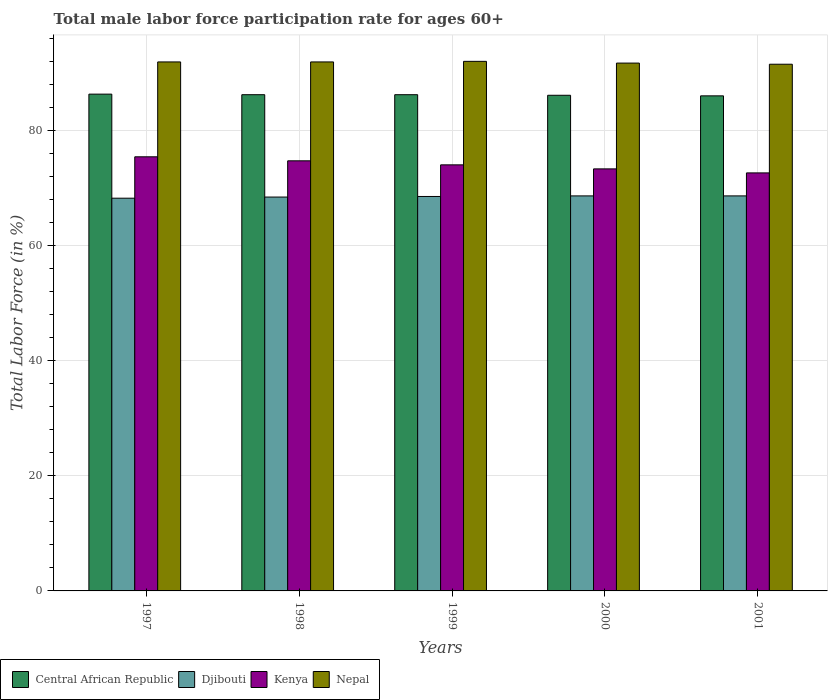How many different coloured bars are there?
Ensure brevity in your answer.  4. How many groups of bars are there?
Make the answer very short. 5. How many bars are there on the 5th tick from the left?
Your answer should be compact. 4. What is the male labor force participation rate in Kenya in 2000?
Ensure brevity in your answer.  73.4. Across all years, what is the maximum male labor force participation rate in Nepal?
Your answer should be very brief. 92.1. Across all years, what is the minimum male labor force participation rate in Djibouti?
Your response must be concise. 68.3. In which year was the male labor force participation rate in Nepal minimum?
Offer a very short reply. 2001. What is the total male labor force participation rate in Nepal in the graph?
Your answer should be very brief. 459.5. What is the difference between the male labor force participation rate in Kenya in 1997 and that in 1999?
Offer a very short reply. 1.4. What is the difference between the male labor force participation rate in Kenya in 1997 and the male labor force participation rate in Central African Republic in 1999?
Ensure brevity in your answer.  -10.8. What is the average male labor force participation rate in Djibouti per year?
Your answer should be very brief. 68.56. In the year 1999, what is the difference between the male labor force participation rate in Central African Republic and male labor force participation rate in Kenya?
Your answer should be compact. 12.2. In how many years, is the male labor force participation rate in Djibouti greater than 36 %?
Your answer should be compact. 5. What is the ratio of the male labor force participation rate in Djibouti in 1998 to that in 1999?
Provide a short and direct response. 1. What is the difference between the highest and the second highest male labor force participation rate in Nepal?
Give a very brief answer. 0.1. What is the difference between the highest and the lowest male labor force participation rate in Djibouti?
Ensure brevity in your answer.  0.4. In how many years, is the male labor force participation rate in Djibouti greater than the average male labor force participation rate in Djibouti taken over all years?
Provide a short and direct response. 3. Is it the case that in every year, the sum of the male labor force participation rate in Djibouti and male labor force participation rate in Kenya is greater than the sum of male labor force participation rate in Central African Republic and male labor force participation rate in Nepal?
Offer a very short reply. No. What does the 2nd bar from the left in 1997 represents?
Ensure brevity in your answer.  Djibouti. What does the 1st bar from the right in 1998 represents?
Offer a very short reply. Nepal. Is it the case that in every year, the sum of the male labor force participation rate in Djibouti and male labor force participation rate in Nepal is greater than the male labor force participation rate in Kenya?
Keep it short and to the point. Yes. Are the values on the major ticks of Y-axis written in scientific E-notation?
Make the answer very short. No. Does the graph contain any zero values?
Provide a short and direct response. No. Does the graph contain grids?
Your answer should be very brief. Yes. How many legend labels are there?
Make the answer very short. 4. How are the legend labels stacked?
Make the answer very short. Horizontal. What is the title of the graph?
Your answer should be compact. Total male labor force participation rate for ages 60+. What is the label or title of the X-axis?
Keep it short and to the point. Years. What is the label or title of the Y-axis?
Keep it short and to the point. Total Labor Force (in %). What is the Total Labor Force (in %) in Central African Republic in 1997?
Offer a very short reply. 86.4. What is the Total Labor Force (in %) in Djibouti in 1997?
Make the answer very short. 68.3. What is the Total Labor Force (in %) in Kenya in 1997?
Give a very brief answer. 75.5. What is the Total Labor Force (in %) of Nepal in 1997?
Ensure brevity in your answer.  92. What is the Total Labor Force (in %) of Central African Republic in 1998?
Make the answer very short. 86.3. What is the Total Labor Force (in %) in Djibouti in 1998?
Your answer should be compact. 68.5. What is the Total Labor Force (in %) in Kenya in 1998?
Offer a terse response. 74.8. What is the Total Labor Force (in %) in Nepal in 1998?
Give a very brief answer. 92. What is the Total Labor Force (in %) of Central African Republic in 1999?
Keep it short and to the point. 86.3. What is the Total Labor Force (in %) of Djibouti in 1999?
Your response must be concise. 68.6. What is the Total Labor Force (in %) of Kenya in 1999?
Your response must be concise. 74.1. What is the Total Labor Force (in %) in Nepal in 1999?
Keep it short and to the point. 92.1. What is the Total Labor Force (in %) in Central African Republic in 2000?
Keep it short and to the point. 86.2. What is the Total Labor Force (in %) of Djibouti in 2000?
Provide a short and direct response. 68.7. What is the Total Labor Force (in %) in Kenya in 2000?
Your answer should be compact. 73.4. What is the Total Labor Force (in %) of Nepal in 2000?
Provide a succinct answer. 91.8. What is the Total Labor Force (in %) of Central African Republic in 2001?
Your answer should be very brief. 86.1. What is the Total Labor Force (in %) in Djibouti in 2001?
Your answer should be compact. 68.7. What is the Total Labor Force (in %) of Kenya in 2001?
Give a very brief answer. 72.7. What is the Total Labor Force (in %) of Nepal in 2001?
Offer a very short reply. 91.6. Across all years, what is the maximum Total Labor Force (in %) of Central African Republic?
Your response must be concise. 86.4. Across all years, what is the maximum Total Labor Force (in %) in Djibouti?
Your answer should be very brief. 68.7. Across all years, what is the maximum Total Labor Force (in %) in Kenya?
Your answer should be compact. 75.5. Across all years, what is the maximum Total Labor Force (in %) of Nepal?
Provide a short and direct response. 92.1. Across all years, what is the minimum Total Labor Force (in %) in Central African Republic?
Keep it short and to the point. 86.1. Across all years, what is the minimum Total Labor Force (in %) in Djibouti?
Provide a succinct answer. 68.3. Across all years, what is the minimum Total Labor Force (in %) in Kenya?
Your answer should be very brief. 72.7. Across all years, what is the minimum Total Labor Force (in %) in Nepal?
Give a very brief answer. 91.6. What is the total Total Labor Force (in %) in Central African Republic in the graph?
Offer a terse response. 431.3. What is the total Total Labor Force (in %) of Djibouti in the graph?
Your answer should be compact. 342.8. What is the total Total Labor Force (in %) of Kenya in the graph?
Make the answer very short. 370.5. What is the total Total Labor Force (in %) of Nepal in the graph?
Ensure brevity in your answer.  459.5. What is the difference between the Total Labor Force (in %) of Central African Republic in 1997 and that in 1998?
Keep it short and to the point. 0.1. What is the difference between the Total Labor Force (in %) of Kenya in 1997 and that in 1998?
Keep it short and to the point. 0.7. What is the difference between the Total Labor Force (in %) of Nepal in 1997 and that in 1998?
Provide a succinct answer. 0. What is the difference between the Total Labor Force (in %) of Central African Republic in 1997 and that in 1999?
Offer a very short reply. 0.1. What is the difference between the Total Labor Force (in %) in Kenya in 1997 and that in 1999?
Your response must be concise. 1.4. What is the difference between the Total Labor Force (in %) of Central African Republic in 1997 and that in 2000?
Offer a terse response. 0.2. What is the difference between the Total Labor Force (in %) of Nepal in 1997 and that in 2000?
Give a very brief answer. 0.2. What is the difference between the Total Labor Force (in %) in Central African Republic in 1997 and that in 2001?
Offer a terse response. 0.3. What is the difference between the Total Labor Force (in %) of Djibouti in 1997 and that in 2001?
Your answer should be very brief. -0.4. What is the difference between the Total Labor Force (in %) of Kenya in 1997 and that in 2001?
Your response must be concise. 2.8. What is the difference between the Total Labor Force (in %) of Nepal in 1997 and that in 2001?
Your answer should be compact. 0.4. What is the difference between the Total Labor Force (in %) in Central African Republic in 1998 and that in 2000?
Make the answer very short. 0.1. What is the difference between the Total Labor Force (in %) in Djibouti in 1998 and that in 2000?
Provide a succinct answer. -0.2. What is the difference between the Total Labor Force (in %) of Kenya in 1998 and that in 2000?
Ensure brevity in your answer.  1.4. What is the difference between the Total Labor Force (in %) in Djibouti in 1998 and that in 2001?
Give a very brief answer. -0.2. What is the difference between the Total Labor Force (in %) in Nepal in 1998 and that in 2001?
Provide a short and direct response. 0.4. What is the difference between the Total Labor Force (in %) in Djibouti in 1999 and that in 2000?
Offer a very short reply. -0.1. What is the difference between the Total Labor Force (in %) of Kenya in 1999 and that in 2000?
Your answer should be compact. 0.7. What is the difference between the Total Labor Force (in %) of Nepal in 1999 and that in 2000?
Provide a short and direct response. 0.3. What is the difference between the Total Labor Force (in %) in Nepal in 1999 and that in 2001?
Provide a short and direct response. 0.5. What is the difference between the Total Labor Force (in %) in Central African Republic in 2000 and that in 2001?
Your answer should be very brief. 0.1. What is the difference between the Total Labor Force (in %) of Djibouti in 2000 and that in 2001?
Make the answer very short. 0. What is the difference between the Total Labor Force (in %) of Kenya in 2000 and that in 2001?
Keep it short and to the point. 0.7. What is the difference between the Total Labor Force (in %) of Djibouti in 1997 and the Total Labor Force (in %) of Nepal in 1998?
Offer a very short reply. -23.7. What is the difference between the Total Labor Force (in %) in Kenya in 1997 and the Total Labor Force (in %) in Nepal in 1998?
Your answer should be compact. -16.5. What is the difference between the Total Labor Force (in %) of Central African Republic in 1997 and the Total Labor Force (in %) of Djibouti in 1999?
Offer a very short reply. 17.8. What is the difference between the Total Labor Force (in %) of Central African Republic in 1997 and the Total Labor Force (in %) of Nepal in 1999?
Offer a terse response. -5.7. What is the difference between the Total Labor Force (in %) in Djibouti in 1997 and the Total Labor Force (in %) in Kenya in 1999?
Keep it short and to the point. -5.8. What is the difference between the Total Labor Force (in %) in Djibouti in 1997 and the Total Labor Force (in %) in Nepal in 1999?
Offer a very short reply. -23.8. What is the difference between the Total Labor Force (in %) of Kenya in 1997 and the Total Labor Force (in %) of Nepal in 1999?
Make the answer very short. -16.6. What is the difference between the Total Labor Force (in %) in Central African Republic in 1997 and the Total Labor Force (in %) in Kenya in 2000?
Your response must be concise. 13. What is the difference between the Total Labor Force (in %) of Central African Republic in 1997 and the Total Labor Force (in %) of Nepal in 2000?
Your answer should be very brief. -5.4. What is the difference between the Total Labor Force (in %) of Djibouti in 1997 and the Total Labor Force (in %) of Nepal in 2000?
Keep it short and to the point. -23.5. What is the difference between the Total Labor Force (in %) in Kenya in 1997 and the Total Labor Force (in %) in Nepal in 2000?
Give a very brief answer. -16.3. What is the difference between the Total Labor Force (in %) in Central African Republic in 1997 and the Total Labor Force (in %) in Djibouti in 2001?
Provide a short and direct response. 17.7. What is the difference between the Total Labor Force (in %) in Central African Republic in 1997 and the Total Labor Force (in %) in Kenya in 2001?
Your answer should be very brief. 13.7. What is the difference between the Total Labor Force (in %) in Central African Republic in 1997 and the Total Labor Force (in %) in Nepal in 2001?
Your answer should be compact. -5.2. What is the difference between the Total Labor Force (in %) of Djibouti in 1997 and the Total Labor Force (in %) of Nepal in 2001?
Offer a terse response. -23.3. What is the difference between the Total Labor Force (in %) in Kenya in 1997 and the Total Labor Force (in %) in Nepal in 2001?
Your answer should be very brief. -16.1. What is the difference between the Total Labor Force (in %) in Central African Republic in 1998 and the Total Labor Force (in %) in Nepal in 1999?
Your response must be concise. -5.8. What is the difference between the Total Labor Force (in %) of Djibouti in 1998 and the Total Labor Force (in %) of Kenya in 1999?
Ensure brevity in your answer.  -5.6. What is the difference between the Total Labor Force (in %) in Djibouti in 1998 and the Total Labor Force (in %) in Nepal in 1999?
Make the answer very short. -23.6. What is the difference between the Total Labor Force (in %) in Kenya in 1998 and the Total Labor Force (in %) in Nepal in 1999?
Offer a very short reply. -17.3. What is the difference between the Total Labor Force (in %) of Djibouti in 1998 and the Total Labor Force (in %) of Kenya in 2000?
Offer a terse response. -4.9. What is the difference between the Total Labor Force (in %) in Djibouti in 1998 and the Total Labor Force (in %) in Nepal in 2000?
Your answer should be compact. -23.3. What is the difference between the Total Labor Force (in %) of Central African Republic in 1998 and the Total Labor Force (in %) of Djibouti in 2001?
Your answer should be very brief. 17.6. What is the difference between the Total Labor Force (in %) in Central African Republic in 1998 and the Total Labor Force (in %) in Kenya in 2001?
Your answer should be compact. 13.6. What is the difference between the Total Labor Force (in %) of Djibouti in 1998 and the Total Labor Force (in %) of Nepal in 2001?
Offer a terse response. -23.1. What is the difference between the Total Labor Force (in %) of Kenya in 1998 and the Total Labor Force (in %) of Nepal in 2001?
Ensure brevity in your answer.  -16.8. What is the difference between the Total Labor Force (in %) in Central African Republic in 1999 and the Total Labor Force (in %) in Djibouti in 2000?
Your response must be concise. 17.6. What is the difference between the Total Labor Force (in %) of Central African Republic in 1999 and the Total Labor Force (in %) of Kenya in 2000?
Your answer should be very brief. 12.9. What is the difference between the Total Labor Force (in %) in Djibouti in 1999 and the Total Labor Force (in %) in Nepal in 2000?
Your answer should be compact. -23.2. What is the difference between the Total Labor Force (in %) of Kenya in 1999 and the Total Labor Force (in %) of Nepal in 2000?
Provide a short and direct response. -17.7. What is the difference between the Total Labor Force (in %) in Central African Republic in 1999 and the Total Labor Force (in %) in Djibouti in 2001?
Offer a terse response. 17.6. What is the difference between the Total Labor Force (in %) of Central African Republic in 1999 and the Total Labor Force (in %) of Kenya in 2001?
Provide a short and direct response. 13.6. What is the difference between the Total Labor Force (in %) of Central African Republic in 1999 and the Total Labor Force (in %) of Nepal in 2001?
Your answer should be very brief. -5.3. What is the difference between the Total Labor Force (in %) in Djibouti in 1999 and the Total Labor Force (in %) in Nepal in 2001?
Offer a very short reply. -23. What is the difference between the Total Labor Force (in %) of Kenya in 1999 and the Total Labor Force (in %) of Nepal in 2001?
Keep it short and to the point. -17.5. What is the difference between the Total Labor Force (in %) in Central African Republic in 2000 and the Total Labor Force (in %) in Kenya in 2001?
Your answer should be compact. 13.5. What is the difference between the Total Labor Force (in %) of Central African Republic in 2000 and the Total Labor Force (in %) of Nepal in 2001?
Make the answer very short. -5.4. What is the difference between the Total Labor Force (in %) of Djibouti in 2000 and the Total Labor Force (in %) of Kenya in 2001?
Make the answer very short. -4. What is the difference between the Total Labor Force (in %) of Djibouti in 2000 and the Total Labor Force (in %) of Nepal in 2001?
Give a very brief answer. -22.9. What is the difference between the Total Labor Force (in %) in Kenya in 2000 and the Total Labor Force (in %) in Nepal in 2001?
Offer a very short reply. -18.2. What is the average Total Labor Force (in %) of Central African Republic per year?
Give a very brief answer. 86.26. What is the average Total Labor Force (in %) of Djibouti per year?
Provide a short and direct response. 68.56. What is the average Total Labor Force (in %) of Kenya per year?
Offer a very short reply. 74.1. What is the average Total Labor Force (in %) of Nepal per year?
Give a very brief answer. 91.9. In the year 1997, what is the difference between the Total Labor Force (in %) of Central African Republic and Total Labor Force (in %) of Nepal?
Make the answer very short. -5.6. In the year 1997, what is the difference between the Total Labor Force (in %) of Djibouti and Total Labor Force (in %) of Kenya?
Your answer should be compact. -7.2. In the year 1997, what is the difference between the Total Labor Force (in %) of Djibouti and Total Labor Force (in %) of Nepal?
Offer a very short reply. -23.7. In the year 1997, what is the difference between the Total Labor Force (in %) of Kenya and Total Labor Force (in %) of Nepal?
Keep it short and to the point. -16.5. In the year 1998, what is the difference between the Total Labor Force (in %) in Central African Republic and Total Labor Force (in %) in Kenya?
Offer a very short reply. 11.5. In the year 1998, what is the difference between the Total Labor Force (in %) of Central African Republic and Total Labor Force (in %) of Nepal?
Offer a terse response. -5.7. In the year 1998, what is the difference between the Total Labor Force (in %) of Djibouti and Total Labor Force (in %) of Nepal?
Give a very brief answer. -23.5. In the year 1998, what is the difference between the Total Labor Force (in %) of Kenya and Total Labor Force (in %) of Nepal?
Give a very brief answer. -17.2. In the year 1999, what is the difference between the Total Labor Force (in %) in Central African Republic and Total Labor Force (in %) in Djibouti?
Your answer should be compact. 17.7. In the year 1999, what is the difference between the Total Labor Force (in %) in Djibouti and Total Labor Force (in %) in Kenya?
Provide a succinct answer. -5.5. In the year 1999, what is the difference between the Total Labor Force (in %) of Djibouti and Total Labor Force (in %) of Nepal?
Make the answer very short. -23.5. In the year 1999, what is the difference between the Total Labor Force (in %) in Kenya and Total Labor Force (in %) in Nepal?
Your answer should be compact. -18. In the year 2000, what is the difference between the Total Labor Force (in %) in Central African Republic and Total Labor Force (in %) in Kenya?
Keep it short and to the point. 12.8. In the year 2000, what is the difference between the Total Labor Force (in %) of Central African Republic and Total Labor Force (in %) of Nepal?
Keep it short and to the point. -5.6. In the year 2000, what is the difference between the Total Labor Force (in %) in Djibouti and Total Labor Force (in %) in Kenya?
Offer a very short reply. -4.7. In the year 2000, what is the difference between the Total Labor Force (in %) of Djibouti and Total Labor Force (in %) of Nepal?
Make the answer very short. -23.1. In the year 2000, what is the difference between the Total Labor Force (in %) of Kenya and Total Labor Force (in %) of Nepal?
Keep it short and to the point. -18.4. In the year 2001, what is the difference between the Total Labor Force (in %) of Central African Republic and Total Labor Force (in %) of Djibouti?
Your response must be concise. 17.4. In the year 2001, what is the difference between the Total Labor Force (in %) in Central African Republic and Total Labor Force (in %) in Nepal?
Your answer should be compact. -5.5. In the year 2001, what is the difference between the Total Labor Force (in %) in Djibouti and Total Labor Force (in %) in Kenya?
Provide a succinct answer. -4. In the year 2001, what is the difference between the Total Labor Force (in %) in Djibouti and Total Labor Force (in %) in Nepal?
Your response must be concise. -22.9. In the year 2001, what is the difference between the Total Labor Force (in %) in Kenya and Total Labor Force (in %) in Nepal?
Keep it short and to the point. -18.9. What is the ratio of the Total Labor Force (in %) in Central African Republic in 1997 to that in 1998?
Your answer should be compact. 1. What is the ratio of the Total Labor Force (in %) in Kenya in 1997 to that in 1998?
Ensure brevity in your answer.  1.01. What is the ratio of the Total Labor Force (in %) in Kenya in 1997 to that in 1999?
Your answer should be compact. 1.02. What is the ratio of the Total Labor Force (in %) in Nepal in 1997 to that in 1999?
Provide a short and direct response. 1. What is the ratio of the Total Labor Force (in %) of Djibouti in 1997 to that in 2000?
Your response must be concise. 0.99. What is the ratio of the Total Labor Force (in %) in Kenya in 1997 to that in 2000?
Your answer should be very brief. 1.03. What is the ratio of the Total Labor Force (in %) in Nepal in 1997 to that in 2000?
Keep it short and to the point. 1. What is the ratio of the Total Labor Force (in %) of Central African Republic in 1997 to that in 2001?
Make the answer very short. 1. What is the ratio of the Total Labor Force (in %) of Nepal in 1997 to that in 2001?
Ensure brevity in your answer.  1. What is the ratio of the Total Labor Force (in %) in Djibouti in 1998 to that in 1999?
Ensure brevity in your answer.  1. What is the ratio of the Total Labor Force (in %) in Kenya in 1998 to that in 1999?
Offer a terse response. 1.01. What is the ratio of the Total Labor Force (in %) of Nepal in 1998 to that in 1999?
Make the answer very short. 1. What is the ratio of the Total Labor Force (in %) in Central African Republic in 1998 to that in 2000?
Keep it short and to the point. 1. What is the ratio of the Total Labor Force (in %) of Kenya in 1998 to that in 2000?
Offer a terse response. 1.02. What is the ratio of the Total Labor Force (in %) of Kenya in 1998 to that in 2001?
Keep it short and to the point. 1.03. What is the ratio of the Total Labor Force (in %) of Nepal in 1998 to that in 2001?
Give a very brief answer. 1. What is the ratio of the Total Labor Force (in %) in Central African Republic in 1999 to that in 2000?
Your answer should be compact. 1. What is the ratio of the Total Labor Force (in %) in Djibouti in 1999 to that in 2000?
Your answer should be compact. 1. What is the ratio of the Total Labor Force (in %) in Kenya in 1999 to that in 2000?
Your answer should be very brief. 1.01. What is the ratio of the Total Labor Force (in %) in Central African Republic in 1999 to that in 2001?
Your answer should be compact. 1. What is the ratio of the Total Labor Force (in %) in Kenya in 1999 to that in 2001?
Provide a succinct answer. 1.02. What is the ratio of the Total Labor Force (in %) in Central African Republic in 2000 to that in 2001?
Your answer should be compact. 1. What is the ratio of the Total Labor Force (in %) in Djibouti in 2000 to that in 2001?
Make the answer very short. 1. What is the ratio of the Total Labor Force (in %) in Kenya in 2000 to that in 2001?
Give a very brief answer. 1.01. What is the ratio of the Total Labor Force (in %) of Nepal in 2000 to that in 2001?
Keep it short and to the point. 1. What is the difference between the highest and the second highest Total Labor Force (in %) in Djibouti?
Offer a terse response. 0. What is the difference between the highest and the second highest Total Labor Force (in %) of Kenya?
Offer a very short reply. 0.7. What is the difference between the highest and the lowest Total Labor Force (in %) of Djibouti?
Make the answer very short. 0.4. What is the difference between the highest and the lowest Total Labor Force (in %) in Kenya?
Your response must be concise. 2.8. 